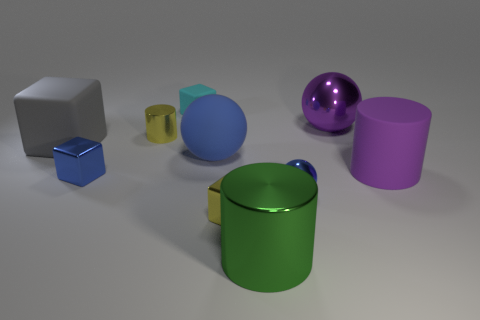Subtract all balls. How many objects are left? 7 Add 2 large blue things. How many large blue things are left? 3 Add 3 big objects. How many big objects exist? 8 Subtract 0 green cubes. How many objects are left? 10 Subtract all small yellow metallic things. Subtract all tiny blue balls. How many objects are left? 7 